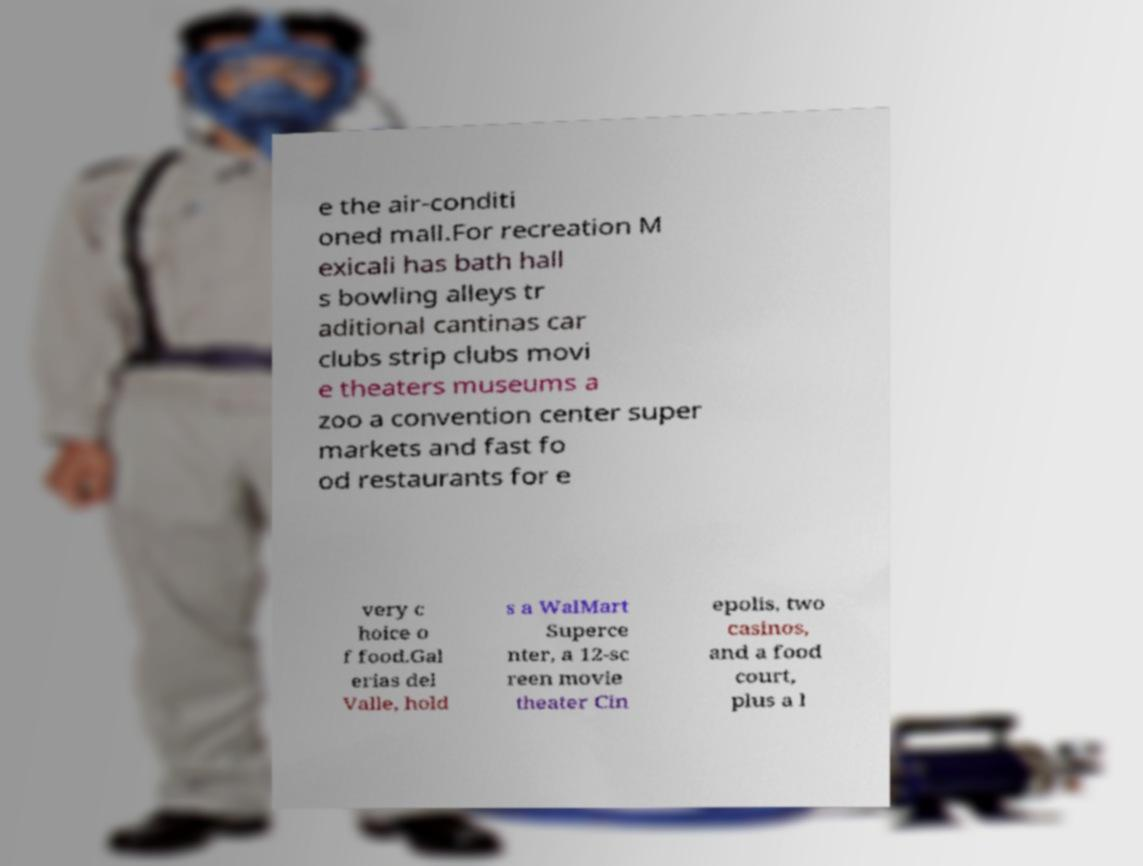What messages or text are displayed in this image? I need them in a readable, typed format. e the air-conditi oned mall.For recreation M exicali has bath hall s bowling alleys tr aditional cantinas car clubs strip clubs movi e theaters museums a zoo a convention center super markets and fast fo od restaurants for e very c hoice o f food.Gal erias del Valle, hold s a WalMart Superce nter, a 12-sc reen movie theater Cin epolis, two casinos, and a food court, plus a l 